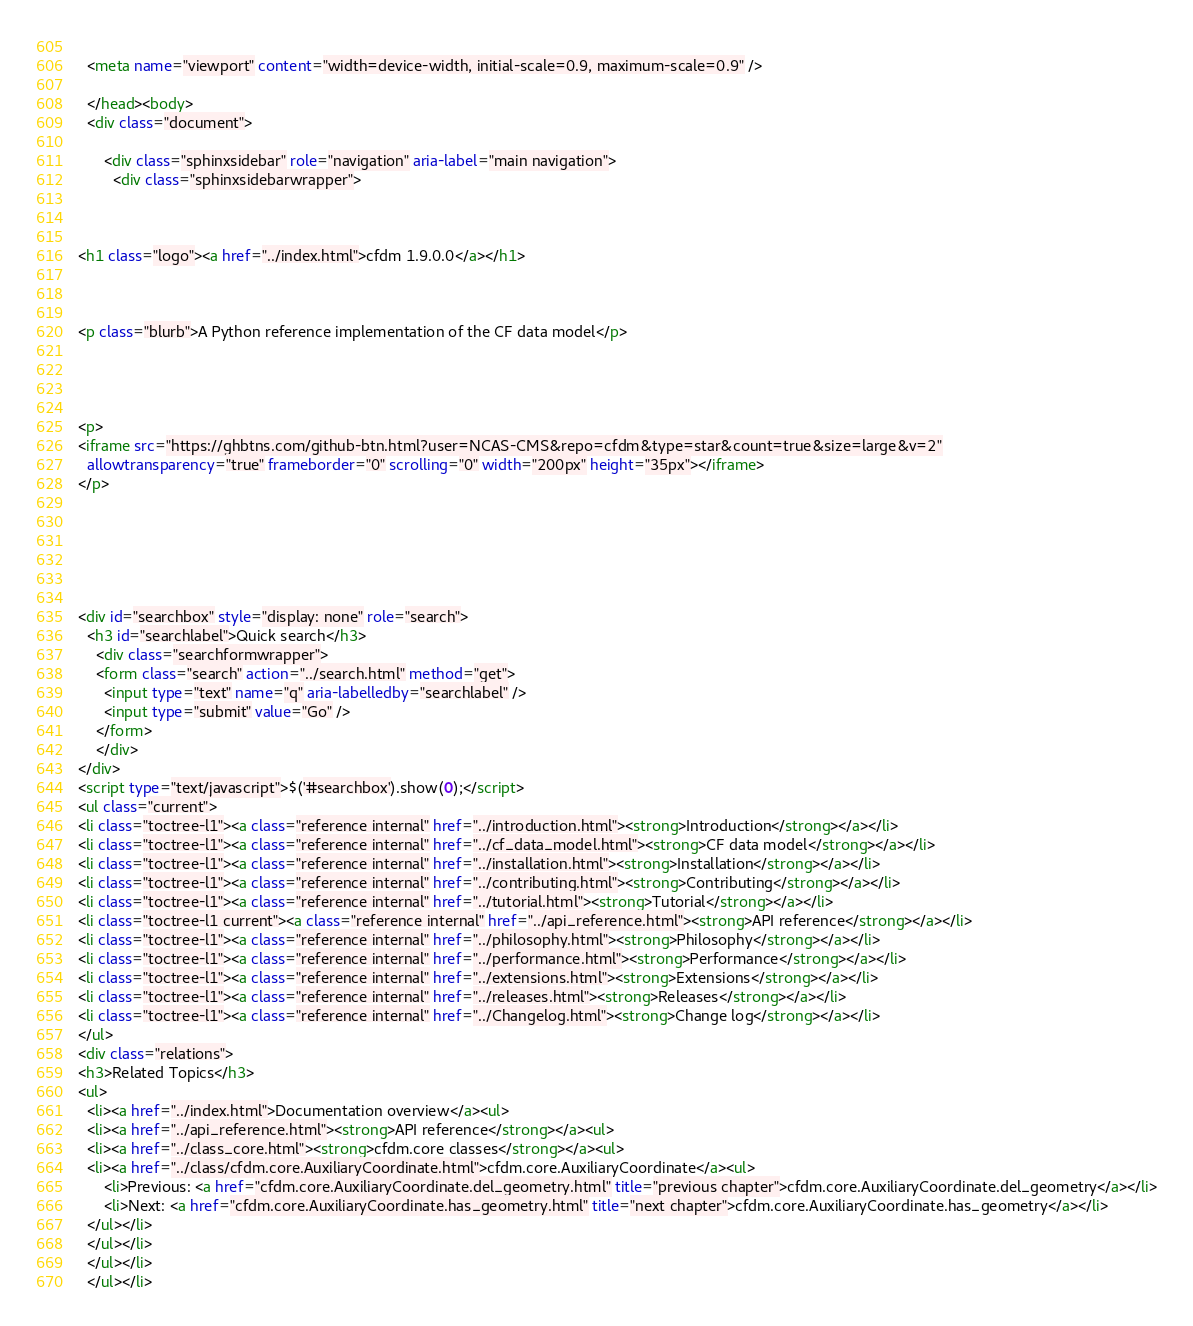Convert code to text. <code><loc_0><loc_0><loc_500><loc_500><_HTML_>  
  <meta name="viewport" content="width=device-width, initial-scale=0.9, maximum-scale=0.9" />

  </head><body>
  <div class="document">
    
      <div class="sphinxsidebar" role="navigation" aria-label="main navigation">
        <div class="sphinxsidebarwrapper">



<h1 class="logo"><a href="../index.html">cfdm 1.9.0.0</a></h1>



<p class="blurb">A Python reference implementation of the CF data model</p>




<p>
<iframe src="https://ghbtns.com/github-btn.html?user=NCAS-CMS&repo=cfdm&type=star&count=true&size=large&v=2"
  allowtransparency="true" frameborder="0" scrolling="0" width="200px" height="35px"></iframe>
</p>






<div id="searchbox" style="display: none" role="search">
  <h3 id="searchlabel">Quick search</h3>
    <div class="searchformwrapper">
    <form class="search" action="../search.html" method="get">
      <input type="text" name="q" aria-labelledby="searchlabel" />
      <input type="submit" value="Go" />
    </form>
    </div>
</div>
<script type="text/javascript">$('#searchbox').show(0);</script>
<ul class="current">
<li class="toctree-l1"><a class="reference internal" href="../introduction.html"><strong>Introduction</strong></a></li>
<li class="toctree-l1"><a class="reference internal" href="../cf_data_model.html"><strong>CF data model</strong></a></li>
<li class="toctree-l1"><a class="reference internal" href="../installation.html"><strong>Installation</strong></a></li>
<li class="toctree-l1"><a class="reference internal" href="../contributing.html"><strong>Contributing</strong></a></li>
<li class="toctree-l1"><a class="reference internal" href="../tutorial.html"><strong>Tutorial</strong></a></li>
<li class="toctree-l1 current"><a class="reference internal" href="../api_reference.html"><strong>API reference</strong></a></li>
<li class="toctree-l1"><a class="reference internal" href="../philosophy.html"><strong>Philosophy</strong></a></li>
<li class="toctree-l1"><a class="reference internal" href="../performance.html"><strong>Performance</strong></a></li>
<li class="toctree-l1"><a class="reference internal" href="../extensions.html"><strong>Extensions</strong></a></li>
<li class="toctree-l1"><a class="reference internal" href="../releases.html"><strong>Releases</strong></a></li>
<li class="toctree-l1"><a class="reference internal" href="../Changelog.html"><strong>Change log</strong></a></li>
</ul>
<div class="relations">
<h3>Related Topics</h3>
<ul>
  <li><a href="../index.html">Documentation overview</a><ul>
  <li><a href="../api_reference.html"><strong>API reference</strong></a><ul>
  <li><a href="../class_core.html"><strong>cfdm.core classes</strong></a><ul>
  <li><a href="../class/cfdm.core.AuxiliaryCoordinate.html">cfdm.core.AuxiliaryCoordinate</a><ul>
      <li>Previous: <a href="cfdm.core.AuxiliaryCoordinate.del_geometry.html" title="previous chapter">cfdm.core.AuxiliaryCoordinate.del_geometry</a></li>
      <li>Next: <a href="cfdm.core.AuxiliaryCoordinate.has_geometry.html" title="next chapter">cfdm.core.AuxiliaryCoordinate.has_geometry</a></li>
  </ul></li>
  </ul></li>
  </ul></li>
  </ul></li></code> 